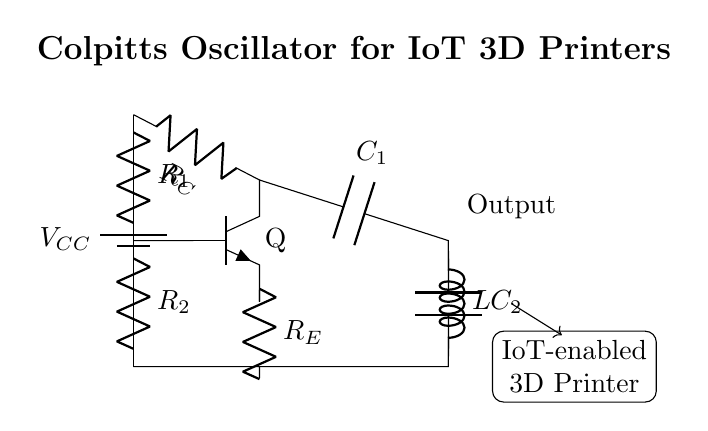What is the type of oscillator shown in the circuit? This circuit uses a Colpitts oscillator configuration, evident from the presence of capacitors in the feedback loop and the arrangement of the LC tank circuit.
Answer: Colpitts What are the values of the capacitors used in the circuit? The circuit shows two capacitors, labeled as C1 and C2, but does not specify their actual values. However, their roles in the oscillator are crucial for the frequency determination.
Answer: Not specified What is the role of the inductor in the circuit? The inductor, labeled as L, is part of the tank circuit with capacitors C1 and C2, crucial for setting the oscillation frequency through the resonance created by this LC configuration.
Answer: Resonance What is the output component of the oscillator? The output is taken from the node connected to the collector of the transistor, where it is labeled as Output in the circuit diagram.
Answer: Output How many resistors are there in the circuit, and what are their labels? There are three resistors in the circuit, labeled as R1, R2, and RC, each serving different purposes in biasing and feedback.
Answer: Three (R1, R2, RC) What is the function of the power supply in this circuit? The power supply, labeled as VCC, provides the necessary voltage to power the circuit components, enabling the transistor to operate and sustain oscillations.
Answer: Power What does the IoT label indicate about this circuit? The IoT label suggests that this Colpitts oscillator is designed to be used in IoT-enabled 3D printers, indicating a practical application in wireless communication.
Answer: IoT-enabled 